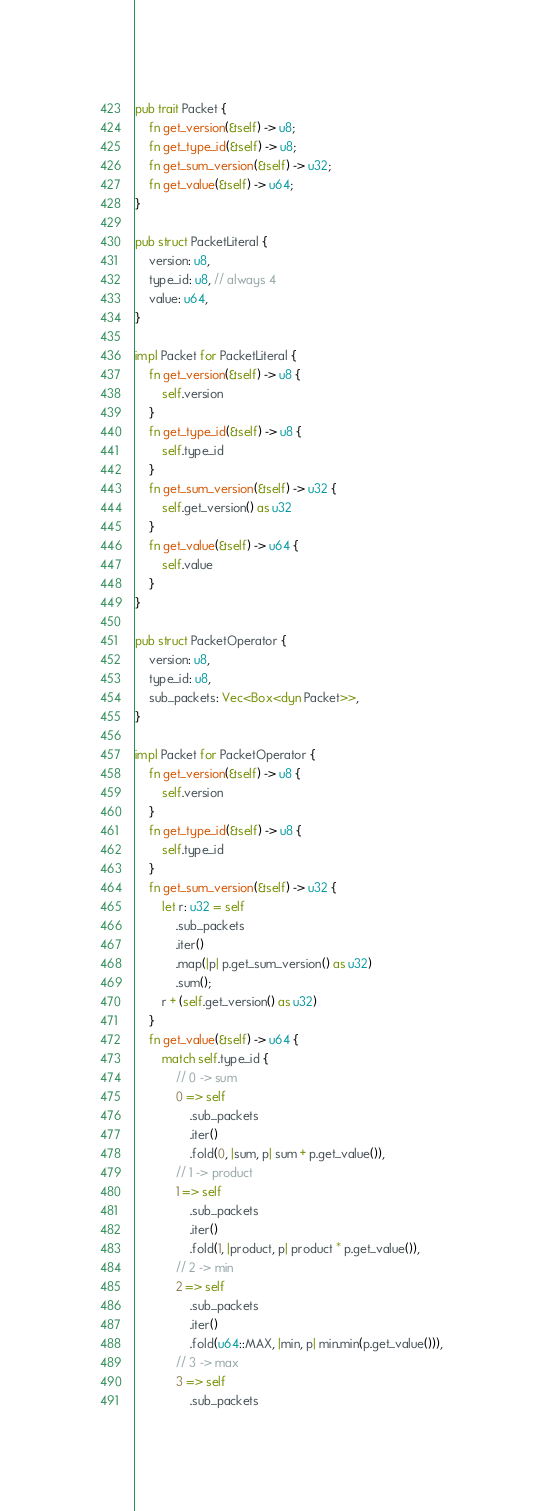Convert code to text. <code><loc_0><loc_0><loc_500><loc_500><_Rust_>pub trait Packet {
    fn get_version(&self) -> u8;
    fn get_type_id(&self) -> u8;
    fn get_sum_version(&self) -> u32;
    fn get_value(&self) -> u64;
}

pub struct PacketLiteral {
    version: u8,
    type_id: u8, // always 4
    value: u64,
}

impl Packet for PacketLiteral {
    fn get_version(&self) -> u8 {
        self.version
    }
    fn get_type_id(&self) -> u8 {
        self.type_id
    }
    fn get_sum_version(&self) -> u32 {
        self.get_version() as u32
    }
    fn get_value(&self) -> u64 {
        self.value
    }
}

pub struct PacketOperator {
    version: u8,
    type_id: u8,
    sub_packets: Vec<Box<dyn Packet>>,
}

impl Packet for PacketOperator {
    fn get_version(&self) -> u8 {
        self.version
    }
    fn get_type_id(&self) -> u8 {
        self.type_id
    }
    fn get_sum_version(&self) -> u32 {
        let r: u32 = self
            .sub_packets
            .iter()
            .map(|p| p.get_sum_version() as u32)
            .sum();
        r + (self.get_version() as u32)
    }
    fn get_value(&self) -> u64 {
        match self.type_id {
            // 0 -> sum
            0 => self
                .sub_packets
                .iter()
                .fold(0, |sum, p| sum + p.get_value()),
            // 1 -> product
            1 => self
                .sub_packets
                .iter()
                .fold(1, |product, p| product * p.get_value()),
            // 2 -> min
            2 => self
                .sub_packets
                .iter()
                .fold(u64::MAX, |min, p| min.min(p.get_value())),
            // 3 -> max
            3 => self
                .sub_packets</code> 